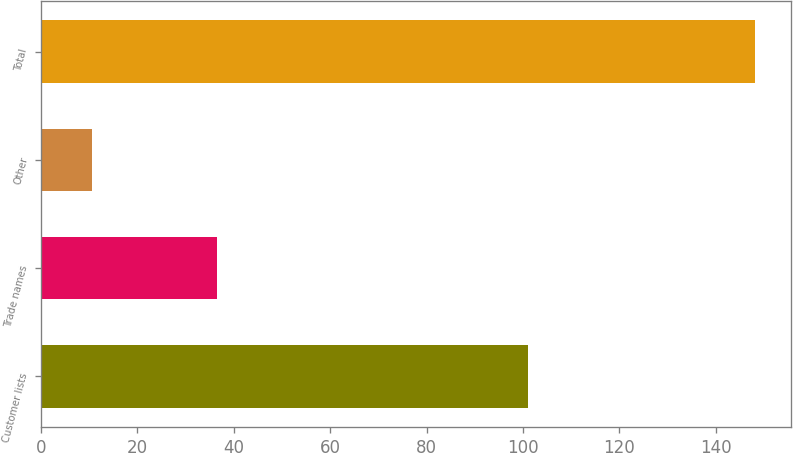Convert chart. <chart><loc_0><loc_0><loc_500><loc_500><bar_chart><fcel>Customer lists<fcel>Trade names<fcel>Other<fcel>Total<nl><fcel>101<fcel>36.6<fcel>10.5<fcel>148.1<nl></chart> 